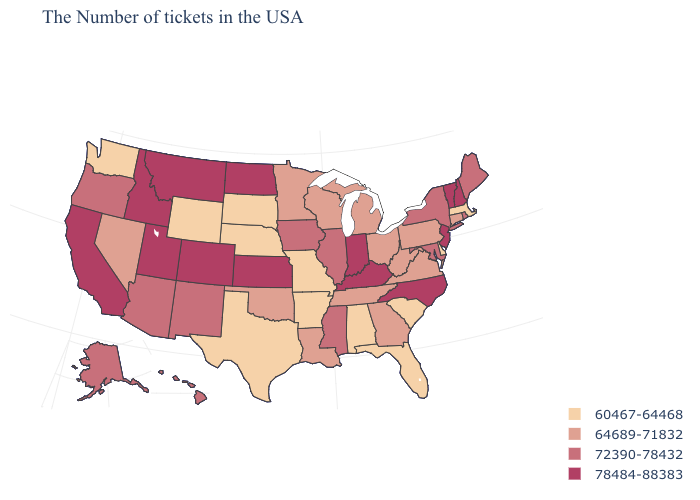Which states have the lowest value in the USA?
Answer briefly. Massachusetts, Delaware, South Carolina, Florida, Alabama, Missouri, Arkansas, Nebraska, Texas, South Dakota, Wyoming, Washington. How many symbols are there in the legend?
Quick response, please. 4. Name the states that have a value in the range 72390-78432?
Short answer required. Maine, Rhode Island, New York, Maryland, Illinois, Mississippi, Iowa, New Mexico, Arizona, Oregon, Alaska, Hawaii. What is the lowest value in the USA?
Short answer required. 60467-64468. What is the highest value in the West ?
Give a very brief answer. 78484-88383. Name the states that have a value in the range 60467-64468?
Give a very brief answer. Massachusetts, Delaware, South Carolina, Florida, Alabama, Missouri, Arkansas, Nebraska, Texas, South Dakota, Wyoming, Washington. Name the states that have a value in the range 60467-64468?
Concise answer only. Massachusetts, Delaware, South Carolina, Florida, Alabama, Missouri, Arkansas, Nebraska, Texas, South Dakota, Wyoming, Washington. Does the map have missing data?
Quick response, please. No. Among the states that border Montana , which have the highest value?
Short answer required. North Dakota, Idaho. How many symbols are there in the legend?
Give a very brief answer. 4. Name the states that have a value in the range 64689-71832?
Short answer required. Connecticut, Pennsylvania, Virginia, West Virginia, Ohio, Georgia, Michigan, Tennessee, Wisconsin, Louisiana, Minnesota, Oklahoma, Nevada. Does the first symbol in the legend represent the smallest category?
Answer briefly. Yes. What is the highest value in states that border North Carolina?
Short answer required. 64689-71832. Which states have the lowest value in the Northeast?
Be succinct. Massachusetts. 